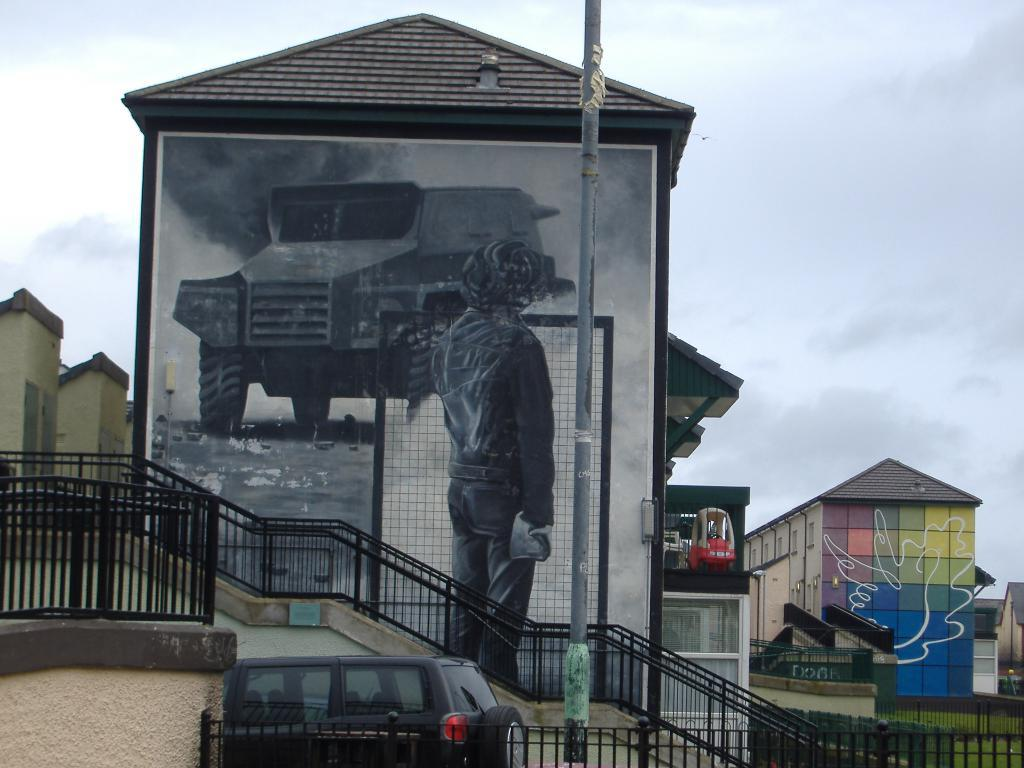What type of structures are depicted in the image? There are buildings with paintings in the image. What other objects can be seen in the image? There is a pole and iron grilles in the image. Is there any transportation visible in the image? Yes, there is a car at the bottom of the image. What can be seen in the background of the image? The sky is visible in the background of the image. What type of appliance is being used to clean the cushion in the image? There is no appliance or cushion present in the image. 